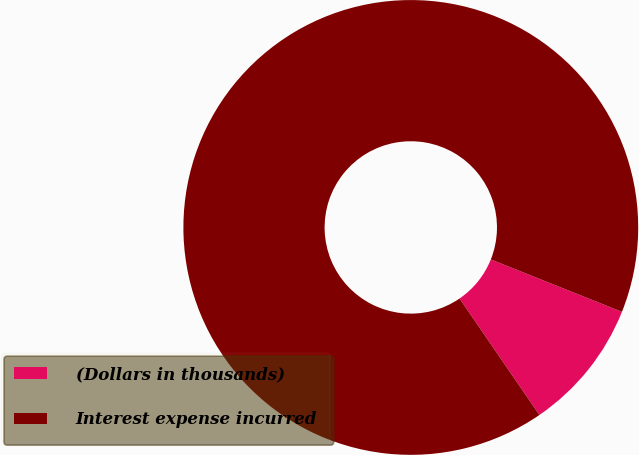<chart> <loc_0><loc_0><loc_500><loc_500><pie_chart><fcel>(Dollars in thousands)<fcel>Interest expense incurred<nl><fcel>9.38%<fcel>90.62%<nl></chart> 